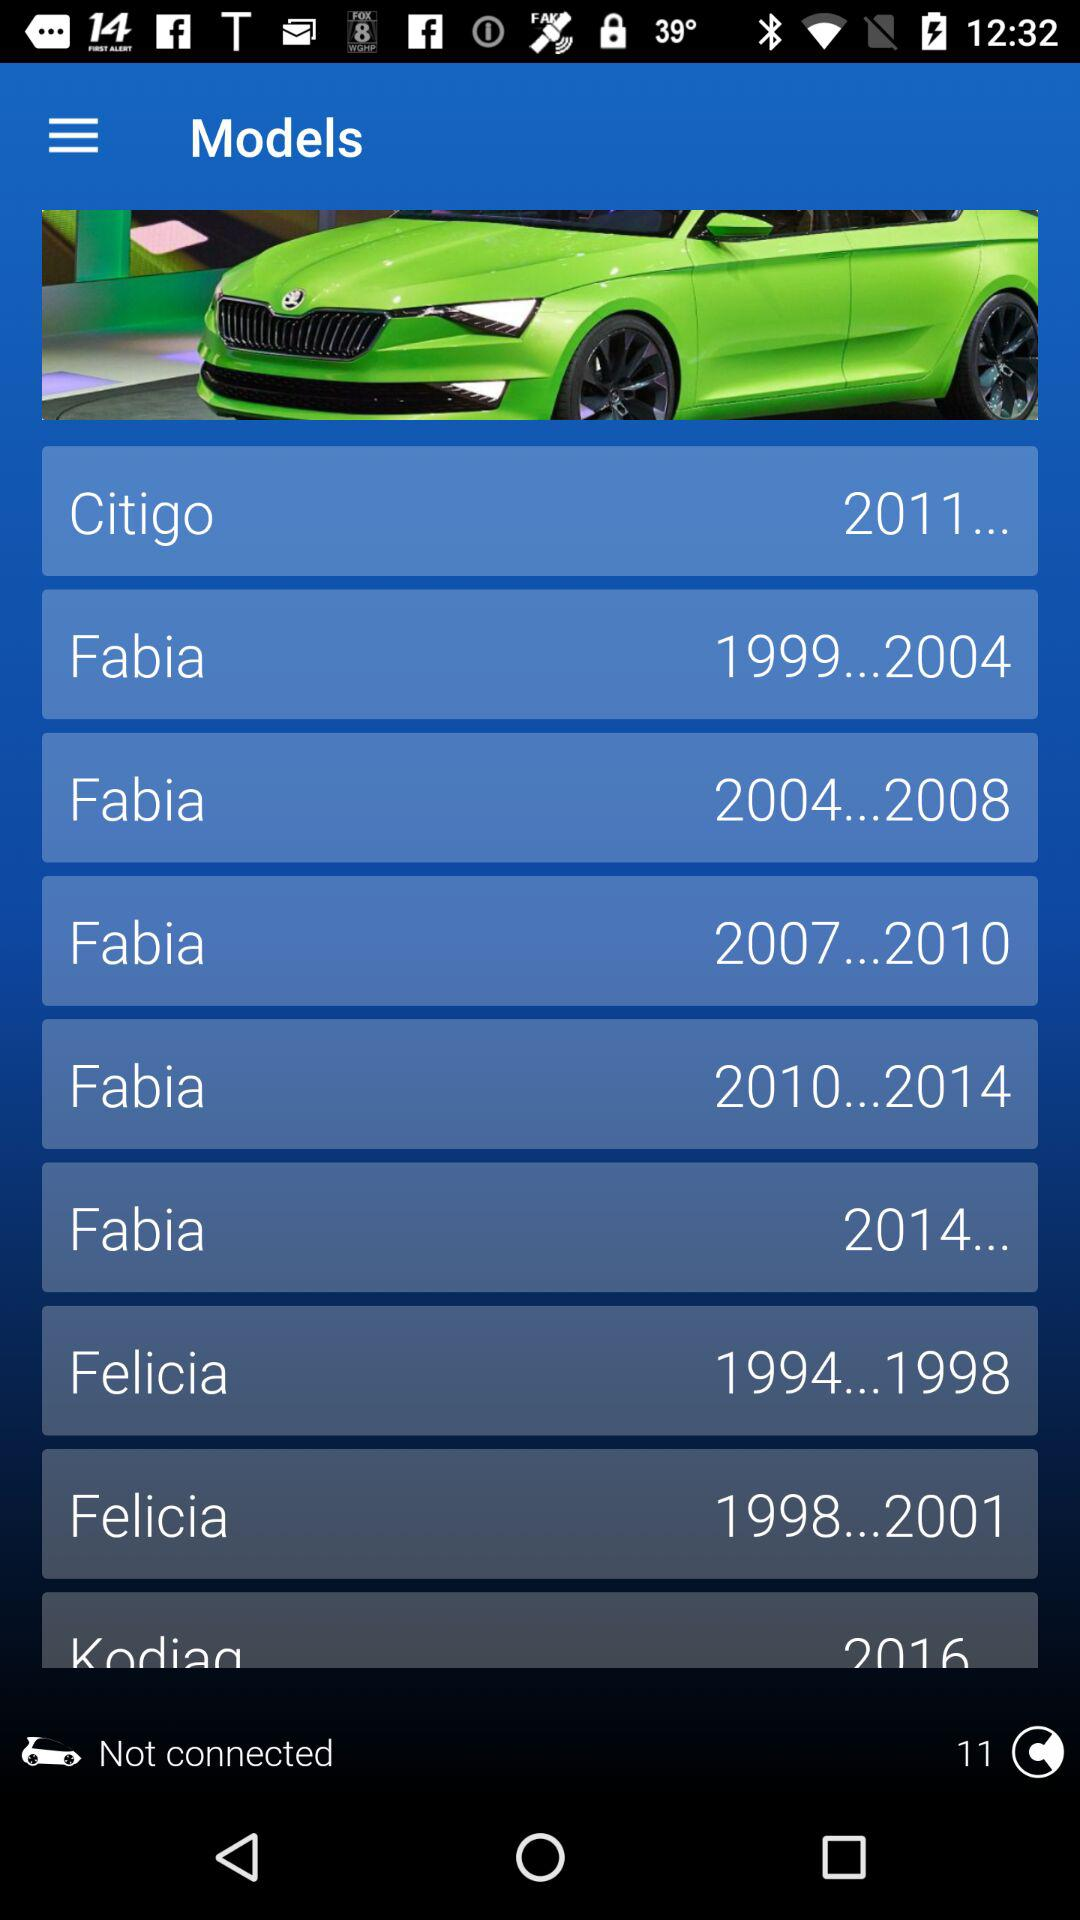How many models are there in total?
Answer the question using a single word or phrase. 9 